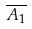Convert formula to latex. <formula><loc_0><loc_0><loc_500><loc_500>\overline { A _ { 1 } }</formula> 